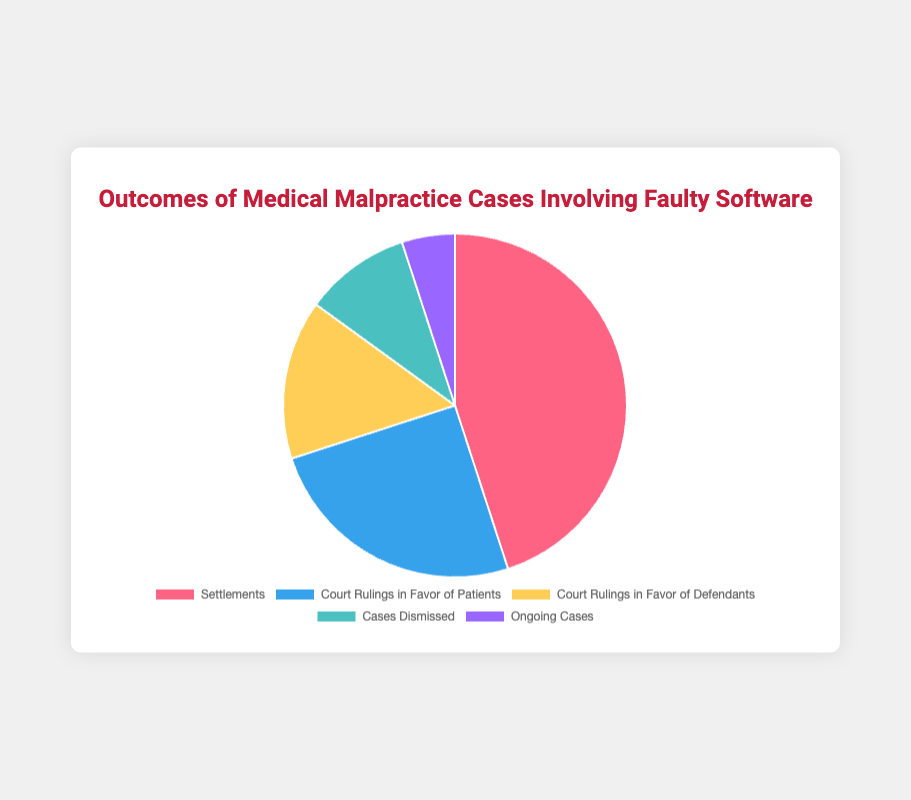How many more cases were settled compared to those dismissed? To find this, we subtract the number of cases dismissed (10) from the number of settlements (45). The calculation is 45 - 10 = 35.
Answer: 35 What is the proportion of ongoing cases compared to the total cases? First, we need the total number of cases: 45 (Settlements) + 25 (Court Rulings in Favor of Patients) + 15 (Court Rulings in Favor of Defendants) + 10 (Cases Dismissed) + 5 (Ongoing Cases) = 100. The proportion of ongoing cases is 5 out of 100, which is 5/100 = 0.05 or 5%.
Answer: 5% Which outcome has the highest number of cases? By visually inspecting the pie chart, we can see that the segment representing Settlements is the largest.
Answer: Settlements Compare the combined count of court rulings against defendants and dismissed cases to the number of settlements. Which is higher and by how much? First, combine the counts: Court Rulings in Favor of Defendants (15) + Cases Dismissed (10) = 25. Compare this to Settlements (45). The difference is 45 - 25 = 20, so settlements are higher by 20 cases.
Answer: Settlements, by 20 What is the percentage of cases that resulted in court rulings in favor of patients? The number of court rulings in favor of patients is 25. The total number of cases is 100. The percentage is (25/100) * 100 = 25%.
Answer: 25% Which outcomes have the same entities involved with overlapping involvement in ongoing cases? Ongoing Cases (Athenahealth, Greenway Health, Cerner Corporation) and Settlements (Cerner Corporation, Epic Systems, McKesson Corporation) both involve Cerner Corporation.
Answer: Settlements and Ongoing Cases If you combine the cases dismissed with the court rulings in favor of defendants, what fraction of the total cases do they represent? The combined count is 15 (Court Rulings in Favor of Defendants) + 10 (Cases Dismissed) = 25. The total number of cases is 100. The fraction is 25/100, which simplifies to 1/4.
Answer: 1/4 Which category represents the smallest portion of the pie chart? By visual inspection, the smallest portion of the pie chart represents Ongoing Cases, which have only 5 cases.
Answer: Ongoing Cases 